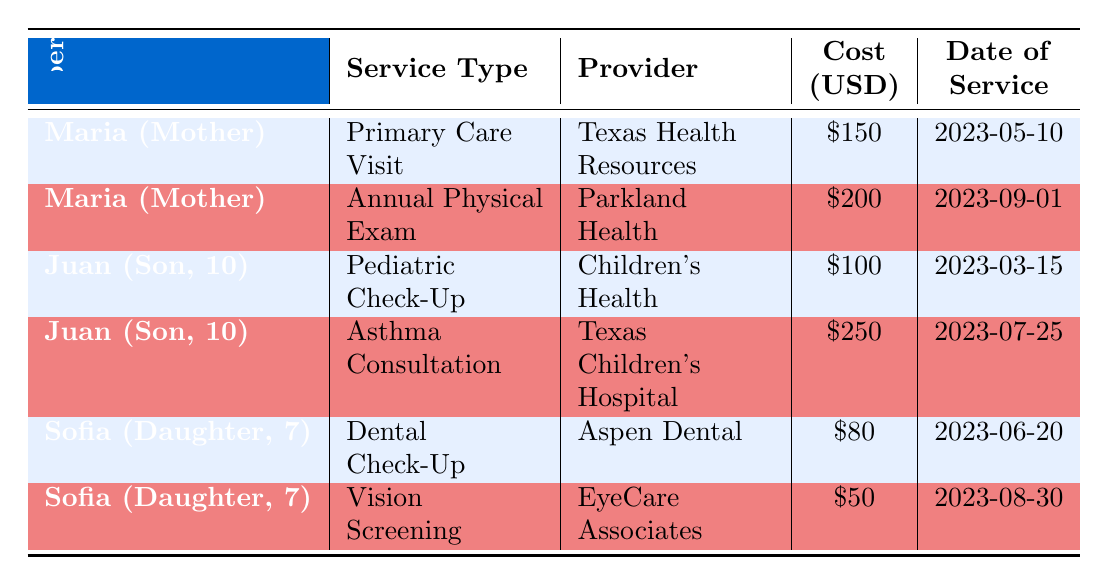What service did Maria receive on May 10, 2023? The table lists the services along with dates. By looking at Maria's entries, I can find that on May 10, 2023, she had a Primary Care Visit.
Answer: Primary Care Visit How much did Juan's asthma consultation cost? Juan's entries are evaluated, and I find that the asthma consultation listed under him shows a cost of 250.
Answer: 250 Did Sofia have insurance coverage for her dental check-up? The table indicates that none of the services received by the family members have insurance coverage. Thus, Sofia did not have insurance coverage for her dental check-up.
Answer: No What was the total cost of healthcare services for all family members listed in the table? To find the total cost, I add the individual costs from the table: 150 (Maria's Primary Care Visit) + 200 (Maria's Annual Physical Exam) + 100 (Juan's Pediatric Check-Up) + 250 (Juan's Asthma Consultation) + 80 (Sofia's Dental Check-Up) + 50 (Sofia's Vision Screening) = 830.
Answer: 830 Which family member had the highest cost for a single service? By comparing all individual costs in the table, I see that Juan's Asthma Consultation cost 250, which is higher than any other single service listed.
Answer: Juan How many services did Maria receive, and what were their names? I check the entries for Maria in the table and find two services: Primary Care Visit and Annual Physical Exam. So, Maria received a total of 2 services.
Answer: 2 services: Primary Care Visit, Annual Physical Exam Was the cost of Juan's services higher than Sofia's combined service costs? Juan's services cost 100 (Pediatric Check-Up) + 250 (Asthma Consultation) = 350 total. Sofia's services cost 80 (Dental Check-Up) + 50 (Vision Screening) = 130 total. Since 350 is greater than 130, Juan's costs are indeed higher.
Answer: Yes What is the average cost of services received by the children? The average cost is calculated by adding the costs of services received by both Juan (100 + 250) and Sofia (80 + 50), which equals 480. This total is divided by 4 (the number of services) resulting in an average of 120.
Answer: 120 